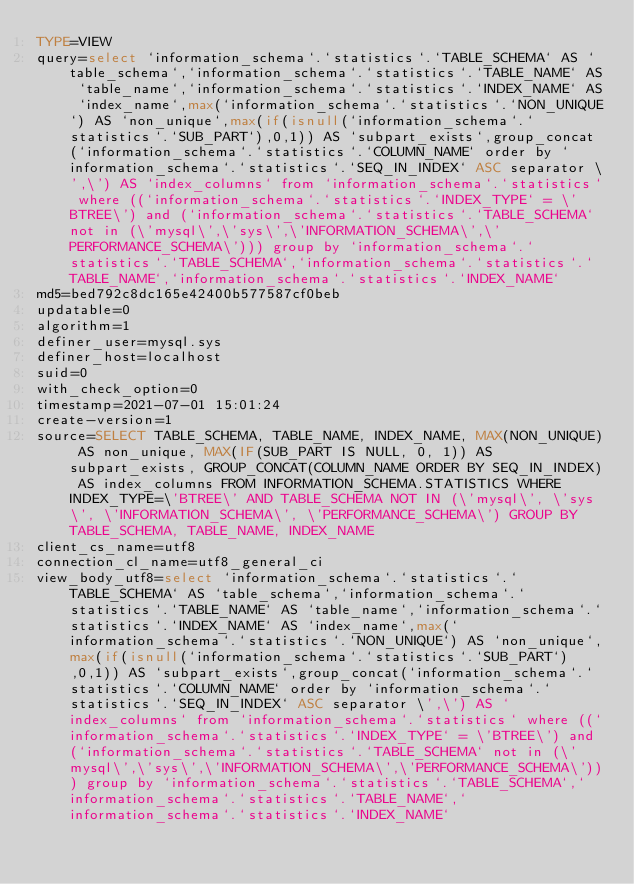<code> <loc_0><loc_0><loc_500><loc_500><_VisualBasic_>TYPE=VIEW
query=select `information_schema`.`statistics`.`TABLE_SCHEMA` AS `table_schema`,`information_schema`.`statistics`.`TABLE_NAME` AS `table_name`,`information_schema`.`statistics`.`INDEX_NAME` AS `index_name`,max(`information_schema`.`statistics`.`NON_UNIQUE`) AS `non_unique`,max(if(isnull(`information_schema`.`statistics`.`SUB_PART`),0,1)) AS `subpart_exists`,group_concat(`information_schema`.`statistics`.`COLUMN_NAME` order by `information_schema`.`statistics`.`SEQ_IN_INDEX` ASC separator \',\') AS `index_columns` from `information_schema`.`statistics` where ((`information_schema`.`statistics`.`INDEX_TYPE` = \'BTREE\') and (`information_schema`.`statistics`.`TABLE_SCHEMA` not in (\'mysql\',\'sys\',\'INFORMATION_SCHEMA\',\'PERFORMANCE_SCHEMA\'))) group by `information_schema`.`statistics`.`TABLE_SCHEMA`,`information_schema`.`statistics`.`TABLE_NAME`,`information_schema`.`statistics`.`INDEX_NAME`
md5=bed792c8dc165e42400b577587cf0beb
updatable=0
algorithm=1
definer_user=mysql.sys
definer_host=localhost
suid=0
with_check_option=0
timestamp=2021-07-01 15:01:24
create-version=1
source=SELECT TABLE_SCHEMA, TABLE_NAME, INDEX_NAME, MAX(NON_UNIQUE) AS non_unique, MAX(IF(SUB_PART IS NULL, 0, 1)) AS subpart_exists, GROUP_CONCAT(COLUMN_NAME ORDER BY SEQ_IN_INDEX) AS index_columns FROM INFORMATION_SCHEMA.STATISTICS WHERE INDEX_TYPE=\'BTREE\' AND TABLE_SCHEMA NOT IN (\'mysql\', \'sys\', \'INFORMATION_SCHEMA\', \'PERFORMANCE_SCHEMA\') GROUP BY TABLE_SCHEMA, TABLE_NAME, INDEX_NAME
client_cs_name=utf8
connection_cl_name=utf8_general_ci
view_body_utf8=select `information_schema`.`statistics`.`TABLE_SCHEMA` AS `table_schema`,`information_schema`.`statistics`.`TABLE_NAME` AS `table_name`,`information_schema`.`statistics`.`INDEX_NAME` AS `index_name`,max(`information_schema`.`statistics`.`NON_UNIQUE`) AS `non_unique`,max(if(isnull(`information_schema`.`statistics`.`SUB_PART`),0,1)) AS `subpart_exists`,group_concat(`information_schema`.`statistics`.`COLUMN_NAME` order by `information_schema`.`statistics`.`SEQ_IN_INDEX` ASC separator \',\') AS `index_columns` from `information_schema`.`statistics` where ((`information_schema`.`statistics`.`INDEX_TYPE` = \'BTREE\') and (`information_schema`.`statistics`.`TABLE_SCHEMA` not in (\'mysql\',\'sys\',\'INFORMATION_SCHEMA\',\'PERFORMANCE_SCHEMA\'))) group by `information_schema`.`statistics`.`TABLE_SCHEMA`,`information_schema`.`statistics`.`TABLE_NAME`,`information_schema`.`statistics`.`INDEX_NAME`
</code> 